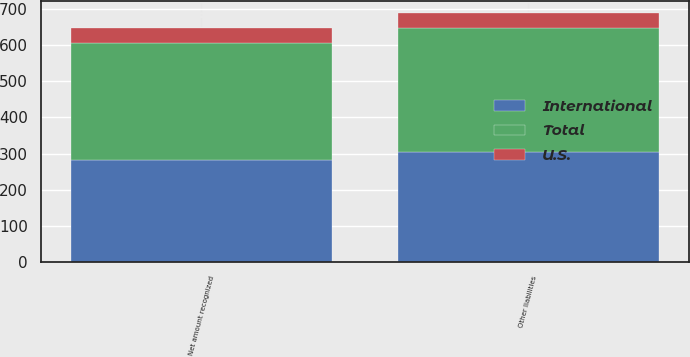<chart> <loc_0><loc_0><loc_500><loc_500><stacked_bar_chart><ecel><fcel>Other liabilities<fcel>Net amount recognized<nl><fcel>U.S.<fcel>39.9<fcel>39.9<nl><fcel>International<fcel>304.1<fcel>283.4<nl><fcel>Total<fcel>344<fcel>323.3<nl></chart> 